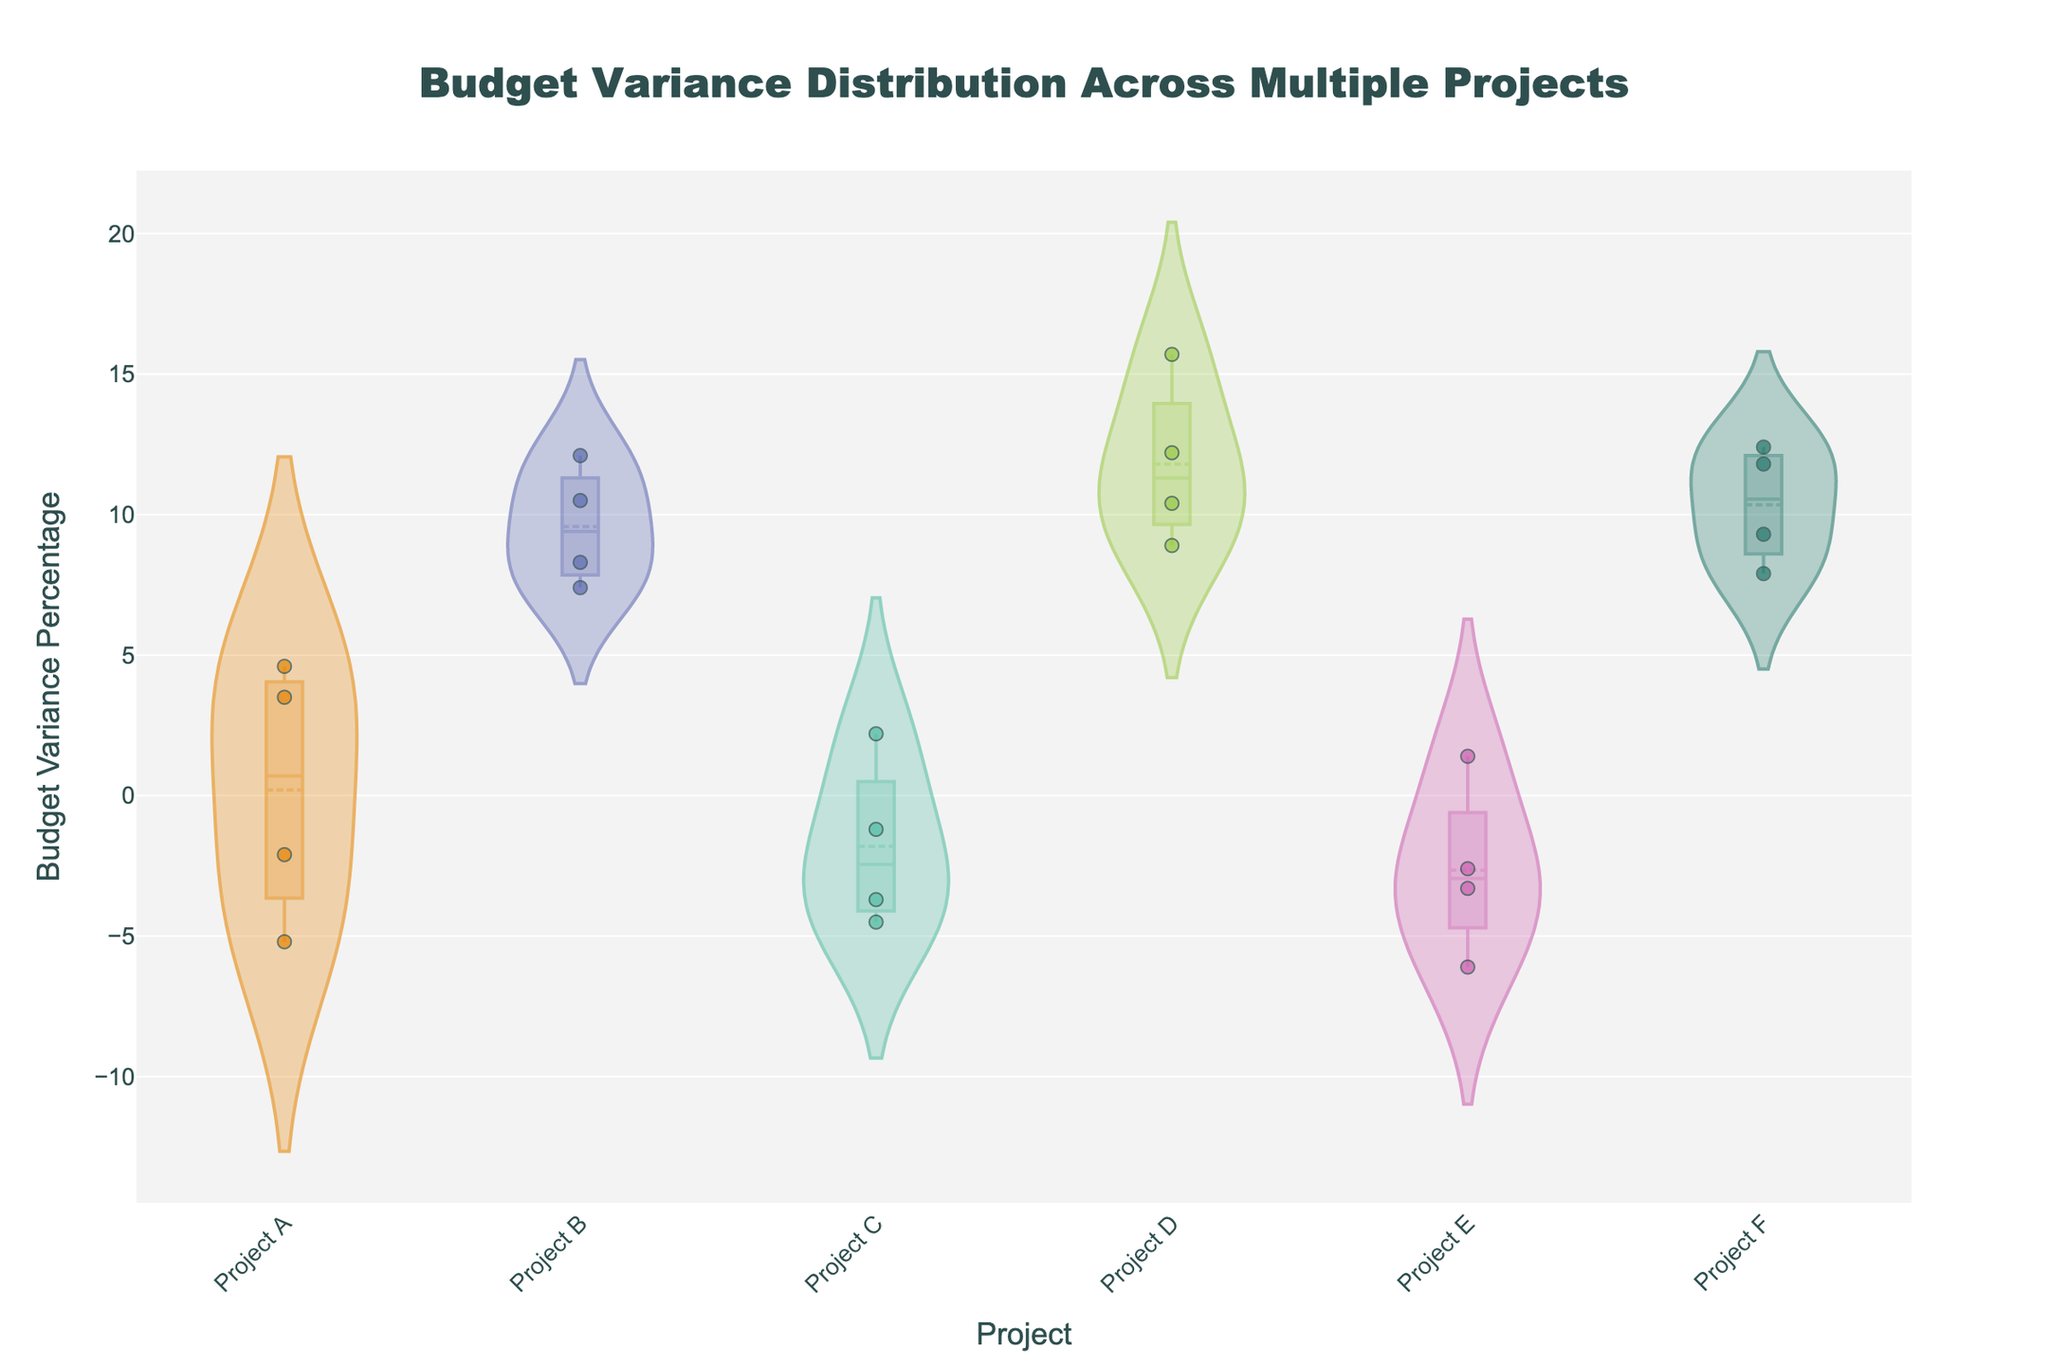What is the title of the chart? The title of the chart is in a prominent position at the top of the figure. It says "Budget Variance Distribution Across Multiple Projects."
Answer: Budget Variance Distribution Across Multiple Projects Which project has the highest positive budget variance? In the jittered points and violin plots, Project D has the maximum positive budget variance around 15.7%.
Answer: Project D How many projects have negative budget variances present? In the chart, Projects A, C, and E have jittered points below the zero line on the y-axis, which indicates negative budget variances.
Answer: 3 What is the average budget variance for Project B? Project B has four values: 10.5, 8.3, 12.1, and 7.4. Summing them gives 38.3 and dividing by 4 gives the average: 38.3/4 = 9.575.
Answer: 9.575 Which project has the widest distribution of budget variances? Look at the width and spread of each violin plot. Project D appears to have the widest distribution based on the spread of its violin plot.
Answer: Project D Are there any projects where the budget variance is consistently positive or negative? By closely observing the jittered points: for Project D and F, all variances are positive. For Project A, C, and E, both positive and negative variances are present.
Answer: Yes, Project D and F Which project has the closest budget variance to zero? By reviewing the jittered points, Project C has a variance closest to zero, around -1.2 and 2.2, which are the nearest to zero.
Answer: Project C Compare the budget variance range of Project A and Project C. Which one has a greater range? Project A ranges from -5.2 to 4.6, yielding a range of 9.8. Project C ranges from -4.5 to 2.2, yielding a range of 6.7. So, Project A has a greater range.
Answer: Project A What is the median budget variance for Project F? The values for Project F are 9.3, 11.8, 7.9, and 12.4. Ordering these is 7.9, 9.3, 11.8, and 12.4, so the median is the average of 9.3 and 11.8: (9.3 + 11.8) / 2 = 10.55.
Answer: 10.55 